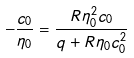Convert formula to latex. <formula><loc_0><loc_0><loc_500><loc_500>- \frac { c _ { 0 } } { \eta _ { 0 } } = \frac { R \eta _ { 0 } ^ { 2 } c _ { 0 } } { q + R \eta _ { 0 } c _ { 0 } ^ { 2 } }</formula> 